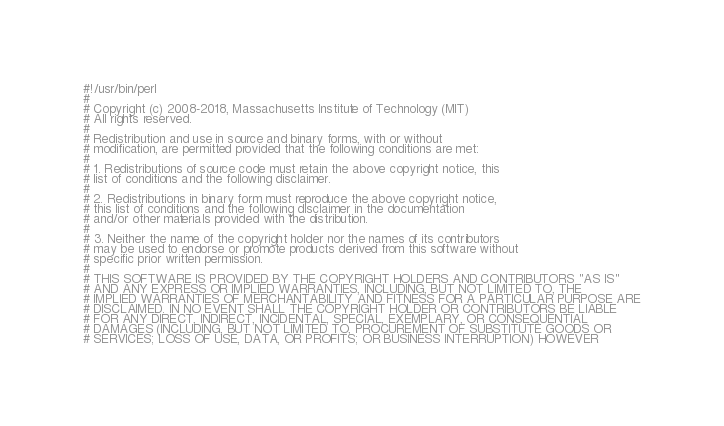<code> <loc_0><loc_0><loc_500><loc_500><_Perl_>#!/usr/bin/perl
#
# Copyright (c) 2008-2018, Massachusetts Institute of Technology (MIT)
# All rights reserved.
#
# Redistribution and use in source and binary forms, with or without
# modification, are permitted provided that the following conditions are met:
#
# 1. Redistributions of source code must retain the above copyright notice, this
# list of conditions and the following disclaimer.
#
# 2. Redistributions in binary form must reproduce the above copyright notice,
# this list of conditions and the following disclaimer in the documentation
# and/or other materials provided with the distribution.
#
# 3. Neither the name of the copyright holder nor the names of its contributors
# may be used to endorse or promote products derived from this software without
# specific prior written permission.
#
# THIS SOFTWARE IS PROVIDED BY THE COPYRIGHT HOLDERS AND CONTRIBUTORS "AS IS"
# AND ANY EXPRESS OR IMPLIED WARRANTIES, INCLUDING, BUT NOT LIMITED TO, THE
# IMPLIED WARRANTIES OF MERCHANTABILITY AND FITNESS FOR A PARTICULAR PURPOSE ARE
# DISCLAIMED. IN NO EVENT SHALL THE COPYRIGHT HOLDER OR CONTRIBUTORS BE LIABLE
# FOR ANY DIRECT, INDIRECT, INCIDENTAL, SPECIAL, EXEMPLARY, OR CONSEQUENTIAL
# DAMAGES (INCLUDING, BUT NOT LIMITED TO, PROCUREMENT OF SUBSTITUTE GOODS OR
# SERVICES; LOSS OF USE, DATA, OR PROFITS; OR BUSINESS INTERRUPTION) HOWEVER</code> 